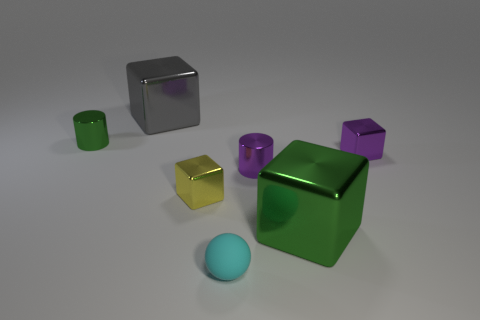Is there any other thing that has the same material as the cyan object?
Offer a very short reply. No. How many matte things are brown cubes or yellow blocks?
Your answer should be compact. 0. What is the size of the green metal object on the right side of the shiny cylinder right of the gray shiny cube?
Your response must be concise. Large. Are there any small purple cubes that are in front of the tiny purple metal object that is to the right of the big block in front of the green shiny cylinder?
Give a very brief answer. No. Do the cylinder on the right side of the big gray object and the tiny thing to the right of the large green shiny thing have the same material?
Offer a terse response. Yes. How many objects are purple metal objects or large gray shiny objects that are behind the small purple shiny cylinder?
Provide a succinct answer. 3. What number of green metallic objects are the same shape as the large gray object?
Provide a succinct answer. 1. There is a purple cube that is the same size as the yellow shiny block; what is it made of?
Your answer should be compact. Metal. How big is the purple metallic object on the left side of the green metallic thing that is in front of the tiny green cylinder on the left side of the tiny cyan matte ball?
Offer a terse response. Small. Does the metallic cylinder that is right of the ball have the same color as the large block to the left of the cyan object?
Ensure brevity in your answer.  No. 